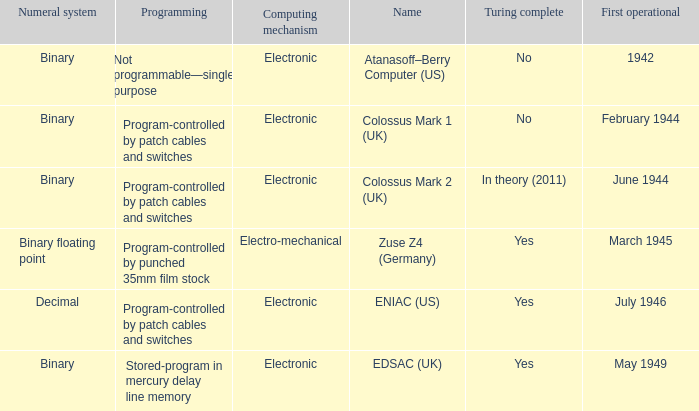What's the first operational with programming being not programmable—single purpose 1942.0. 